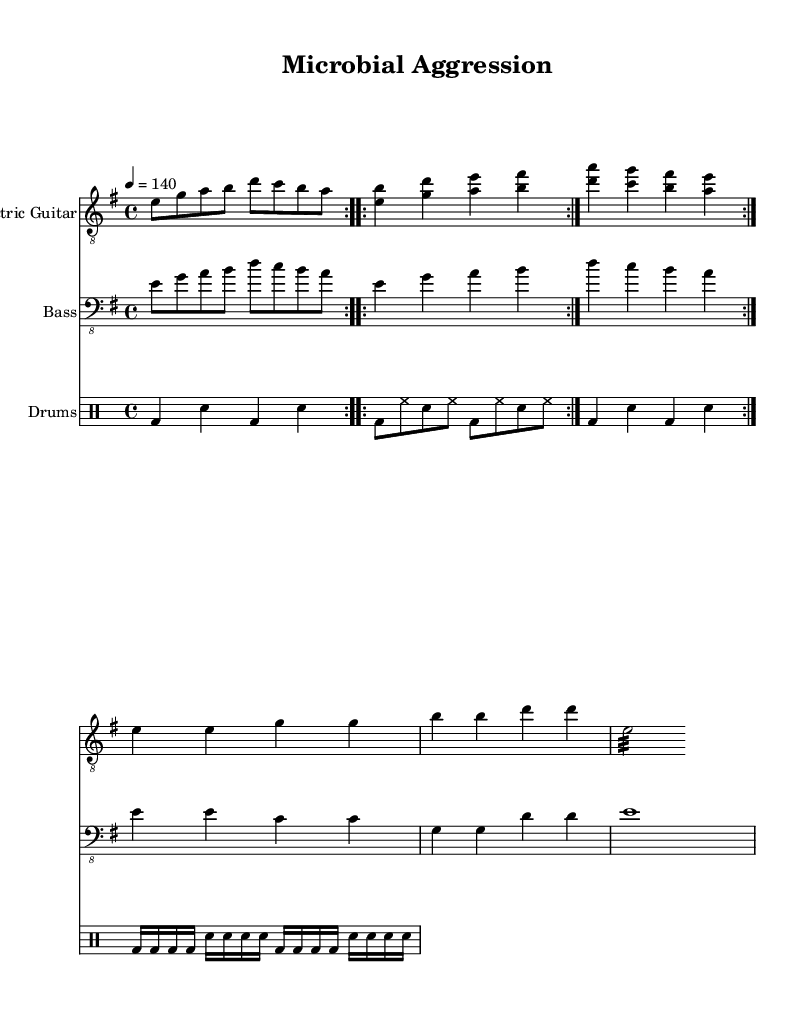What is the key signature of this music? The key signature has two sharps, which correspond to F# and C#; therefore, it is E minor.
Answer: E minor What is the time signature of the piece? The time signature is indicated as 4/4, meaning there are four beats in each measure and a quarter note receives one beat.
Answer: 4/4 What is the tempo marking of this music? The tempo is marked at 140 beats per minute, indicated with the note "4 = 140" suggesting a moderate to fast pace.
Answer: 140 How many measures are in the Intro section? The Intro is repeated twice, and it consists of one measure repeated, resulting in a total of two measures.
Answer: 2 In the Verse section, how many unique chords are played? The Verse section contains seven unique chords as noted in the repeating segments of chord patterns.
Answer: 7 What type of percussion is prominent in this piece? The sheet music indicates a drum part with a bass drum and snare, suggesting heavy use of these instruments typical of Metal music.
Answer: Bass drum and snare How many beats does the Bridge section measure last? The Bridge contains a single measure with a tremolo on an E note that lasts for 16 eighth notes or 2 beats total, but written in shorter notes, hence maintaining the heaviness.
Answer: 1 